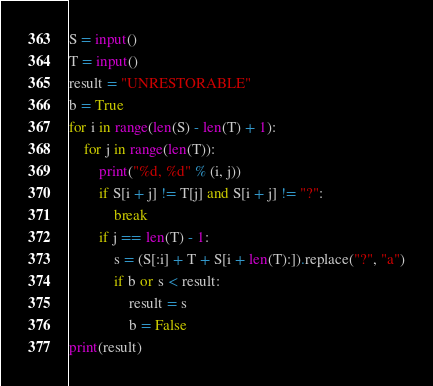Convert code to text. <code><loc_0><loc_0><loc_500><loc_500><_Python_>S = input()
T = input()
result = "UNRESTORABLE"
b = True
for i in range(len(S) - len(T) + 1):
    for j in range(len(T)):
        print("%d, %d" % (i, j))
        if S[i + j] != T[j] and S[i + j] != "?":
            break
        if j == len(T) - 1:
            s = (S[:i] + T + S[i + len(T):]).replace("?", "a")
            if b or s < result:
                result = s
                b = False
print(result)
</code> 